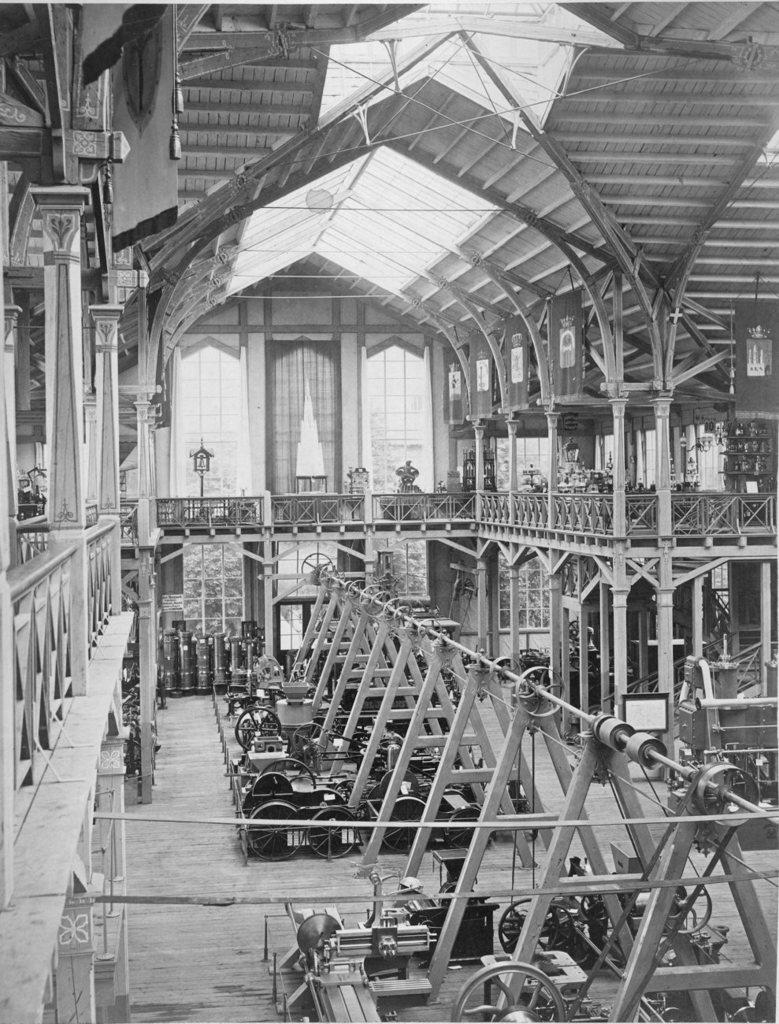What type of objects can be seen in the image? There are machines in the image. What part of the structure is visible at the top of the image? There is a roof visible at the top of the image. Can you hear the guitar playing in the image? There is no guitar present in the image, so it is not possible to hear it playing. 